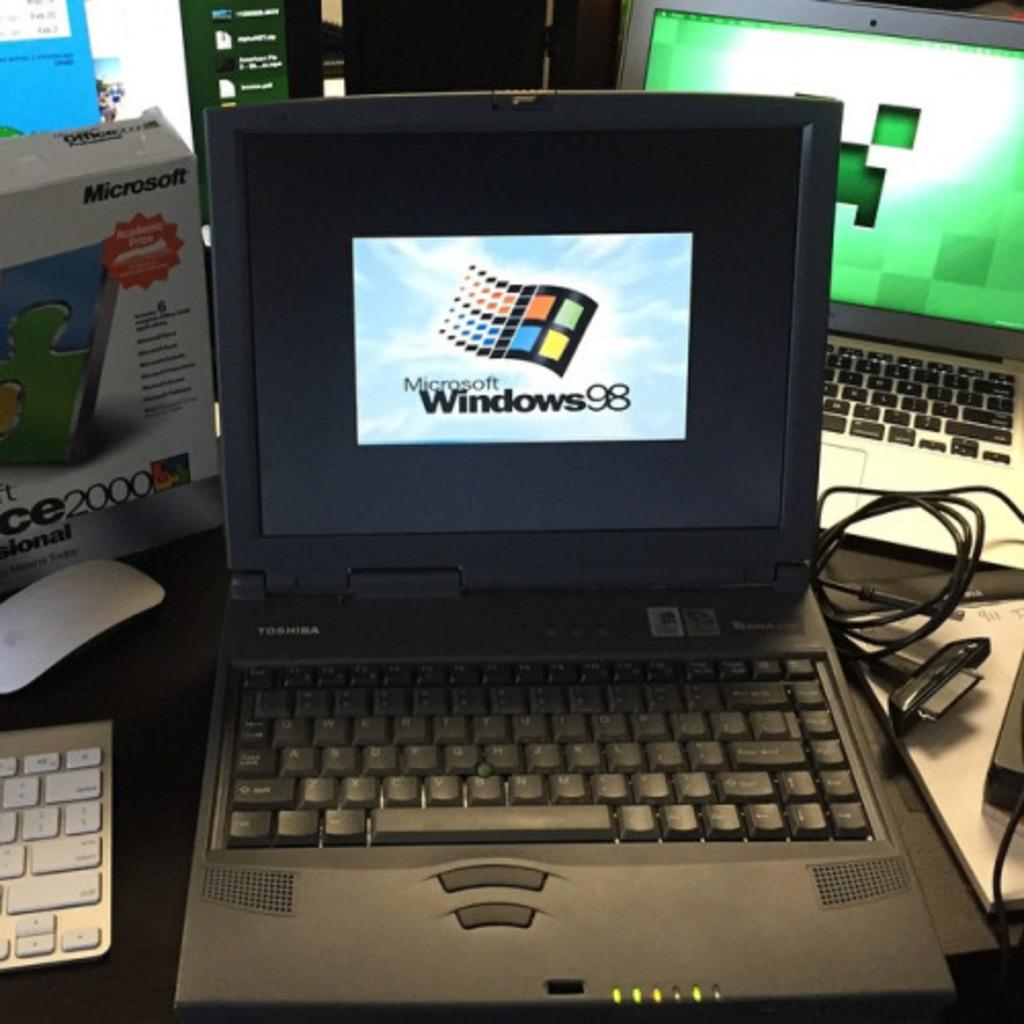Provide a one-sentence caption for the provided image. A Toshiba shows Windows 98 on its screen. 